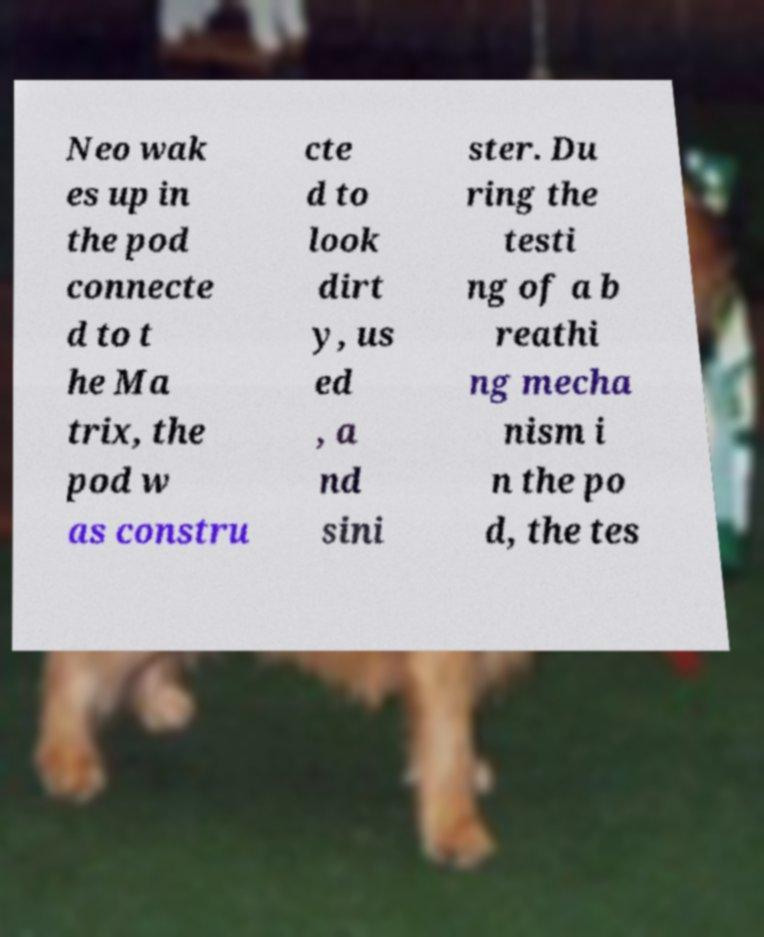For documentation purposes, I need the text within this image transcribed. Could you provide that? Neo wak es up in the pod connecte d to t he Ma trix, the pod w as constru cte d to look dirt y, us ed , a nd sini ster. Du ring the testi ng of a b reathi ng mecha nism i n the po d, the tes 